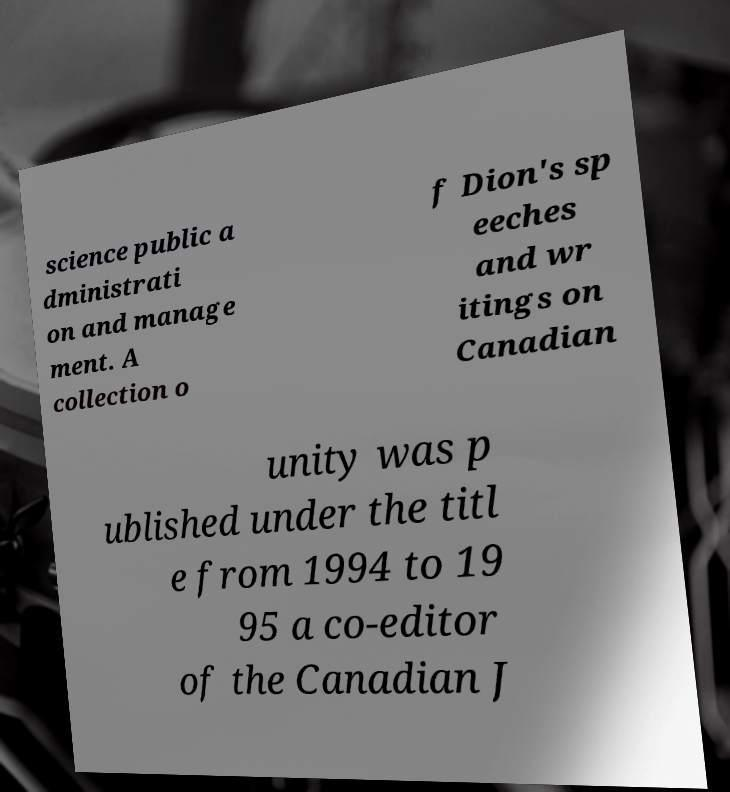There's text embedded in this image that I need extracted. Can you transcribe it verbatim? science public a dministrati on and manage ment. A collection o f Dion's sp eeches and wr itings on Canadian unity was p ublished under the titl e from 1994 to 19 95 a co-editor of the Canadian J 